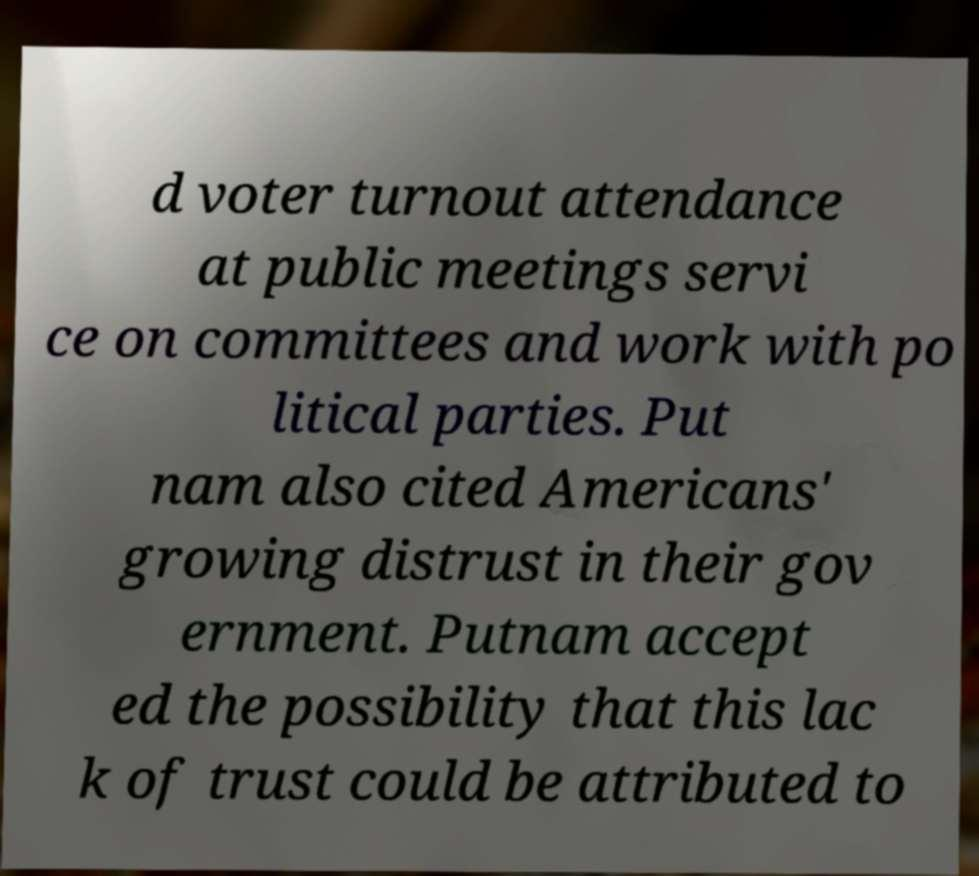Could you assist in decoding the text presented in this image and type it out clearly? d voter turnout attendance at public meetings servi ce on committees and work with po litical parties. Put nam also cited Americans' growing distrust in their gov ernment. Putnam accept ed the possibility that this lac k of trust could be attributed to 